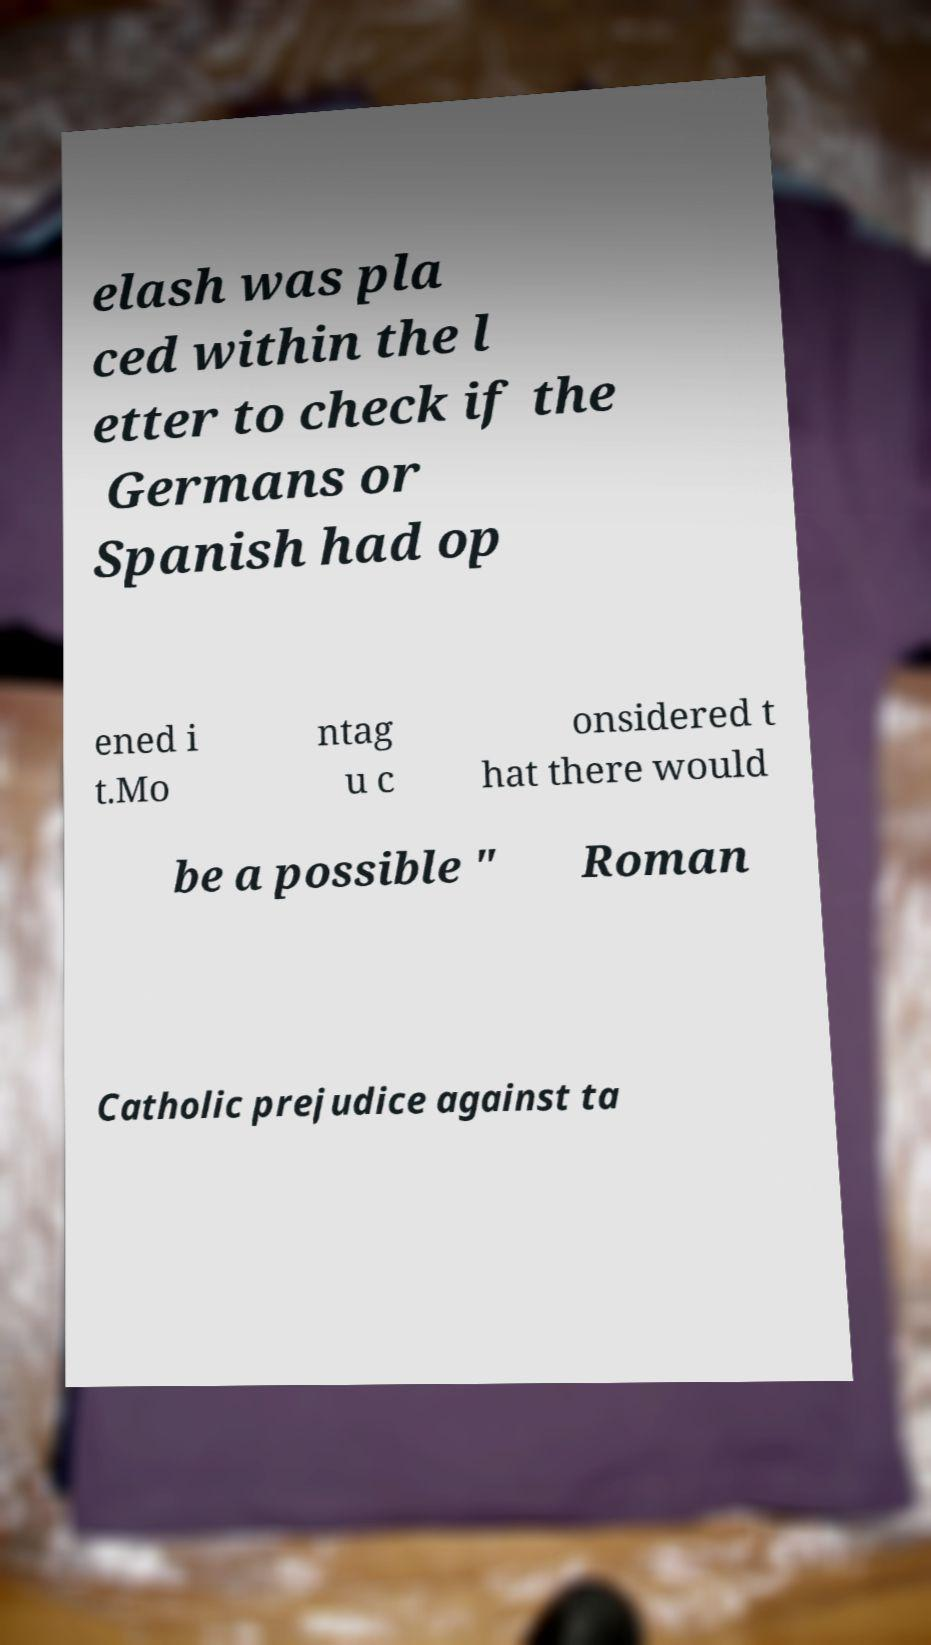Could you extract and type out the text from this image? elash was pla ced within the l etter to check if the Germans or Spanish had op ened i t.Mo ntag u c onsidered t hat there would be a possible " Roman Catholic prejudice against ta 